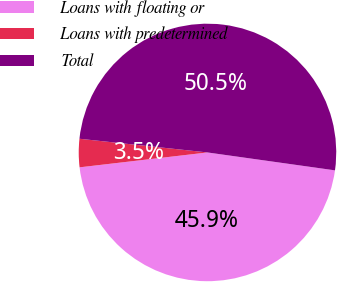Convert chart to OTSL. <chart><loc_0><loc_0><loc_500><loc_500><pie_chart><fcel>Loans with floating or<fcel>Loans with predetermined<fcel>Total<nl><fcel>45.93%<fcel>3.54%<fcel>50.52%<nl></chart> 